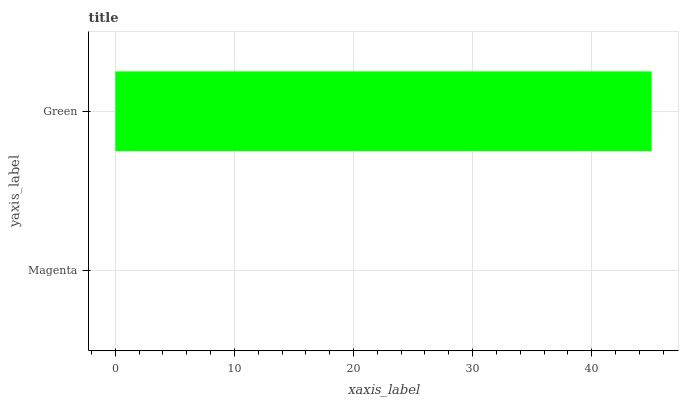Is Magenta the minimum?
Answer yes or no. Yes. Is Green the maximum?
Answer yes or no. Yes. Is Green the minimum?
Answer yes or no. No. Is Green greater than Magenta?
Answer yes or no. Yes. Is Magenta less than Green?
Answer yes or no. Yes. Is Magenta greater than Green?
Answer yes or no. No. Is Green less than Magenta?
Answer yes or no. No. Is Green the high median?
Answer yes or no. Yes. Is Magenta the low median?
Answer yes or no. Yes. Is Magenta the high median?
Answer yes or no. No. Is Green the low median?
Answer yes or no. No. 